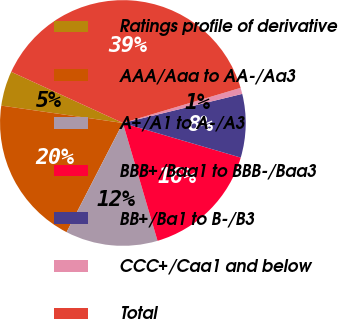Convert chart. <chart><loc_0><loc_0><loc_500><loc_500><pie_chart><fcel>Ratings profile of derivative<fcel>AAA/Aaa to AA-/Aa3<fcel>A+/A1 to A-/A3<fcel>BBB+/Baa1 to BBB-/Baa3<fcel>BB+/Ba1 to B-/B3<fcel>CCC+/Caa1 and below<fcel>Total<nl><fcel>4.58%<fcel>19.68%<fcel>12.13%<fcel>15.9%<fcel>8.35%<fcel>0.81%<fcel>38.55%<nl></chart> 